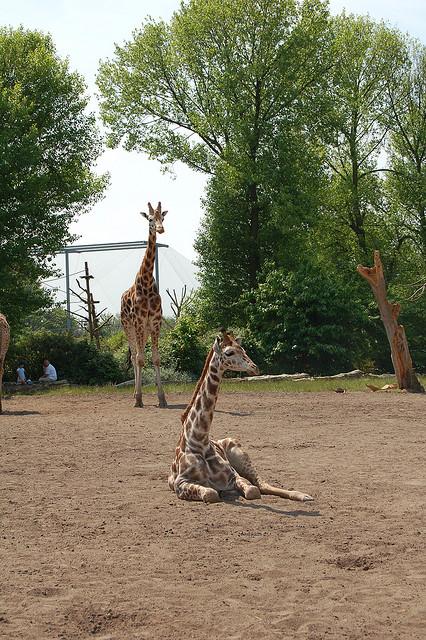Is this a recent photo?
Write a very short answer. Yes. How many giraffes are laying down?
Answer briefly. 1. Are there people near the giraffes?
Keep it brief. Yes. Are the people standing?
Give a very brief answer. No. What kind of animal is this?
Keep it brief. Giraffe. What kind of trees are in the background?
Give a very brief answer. Acacia. 